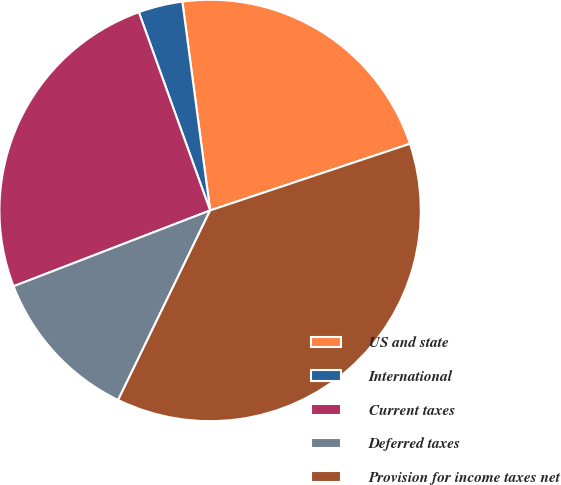<chart> <loc_0><loc_0><loc_500><loc_500><pie_chart><fcel>US and state<fcel>International<fcel>Current taxes<fcel>Deferred taxes<fcel>Provision for income taxes net<nl><fcel>21.98%<fcel>3.39%<fcel>25.37%<fcel>11.95%<fcel>37.32%<nl></chart> 